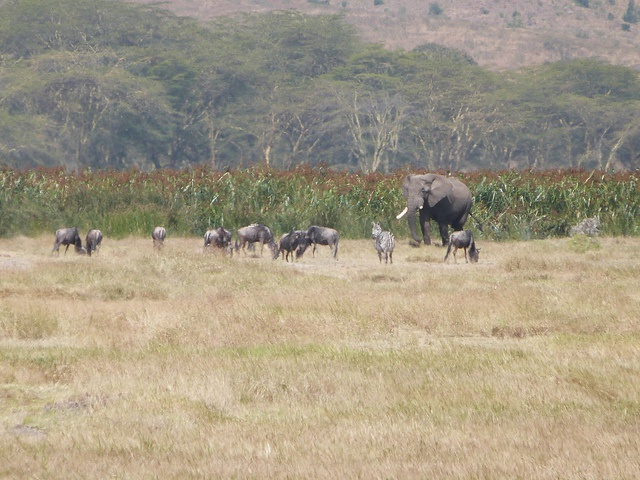Describe the objects in this image and their specific colors. I can see elephant in gray, darkgray, and black tones, cow in gray and darkgray tones, cow in gray, darkgray, and tan tones, cow in gray and darkgray tones, and zebra in gray, darkgray, and lightgray tones in this image. 